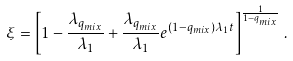Convert formula to latex. <formula><loc_0><loc_0><loc_500><loc_500>\xi = \left [ 1 - \frac { \lambda _ { q _ { m i x } } } { \lambda _ { 1 } } + \frac { \lambda _ { q _ { m i x } } } { \lambda _ { 1 } } e ^ { ( 1 - q _ { m i x } ) \lambda _ { 1 } t } \right ] ^ { \frac { 1 } { 1 - q _ { m i x } } } \, .</formula> 